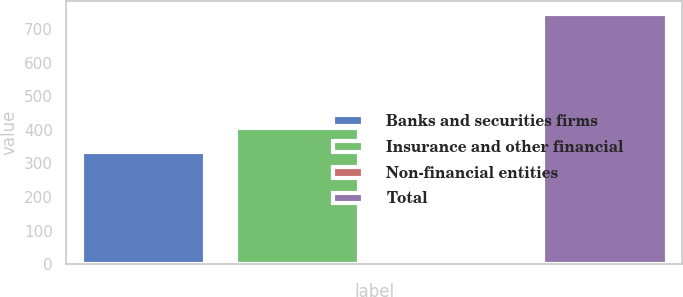Convert chart. <chart><loc_0><loc_0><loc_500><loc_500><bar_chart><fcel>Banks and securities firms<fcel>Insurance and other financial<fcel>Non-financial entities<fcel>Total<nl><fcel>333<fcel>406.8<fcel>8<fcel>746<nl></chart> 